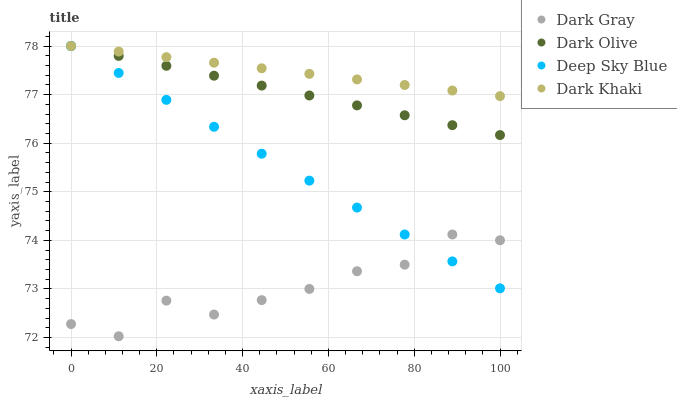Does Dark Gray have the minimum area under the curve?
Answer yes or no. Yes. Does Dark Khaki have the maximum area under the curve?
Answer yes or no. Yes. Does Dark Olive have the minimum area under the curve?
Answer yes or no. No. Does Dark Olive have the maximum area under the curve?
Answer yes or no. No. Is Dark Olive the smoothest?
Answer yes or no. Yes. Is Dark Gray the roughest?
Answer yes or no. Yes. Is Dark Khaki the smoothest?
Answer yes or no. No. Is Dark Khaki the roughest?
Answer yes or no. No. Does Dark Gray have the lowest value?
Answer yes or no. Yes. Does Dark Olive have the lowest value?
Answer yes or no. No. Does Deep Sky Blue have the highest value?
Answer yes or no. Yes. Is Dark Gray less than Dark Khaki?
Answer yes or no. Yes. Is Dark Khaki greater than Dark Gray?
Answer yes or no. Yes. Does Dark Khaki intersect Dark Olive?
Answer yes or no. Yes. Is Dark Khaki less than Dark Olive?
Answer yes or no. No. Is Dark Khaki greater than Dark Olive?
Answer yes or no. No. Does Dark Gray intersect Dark Khaki?
Answer yes or no. No. 